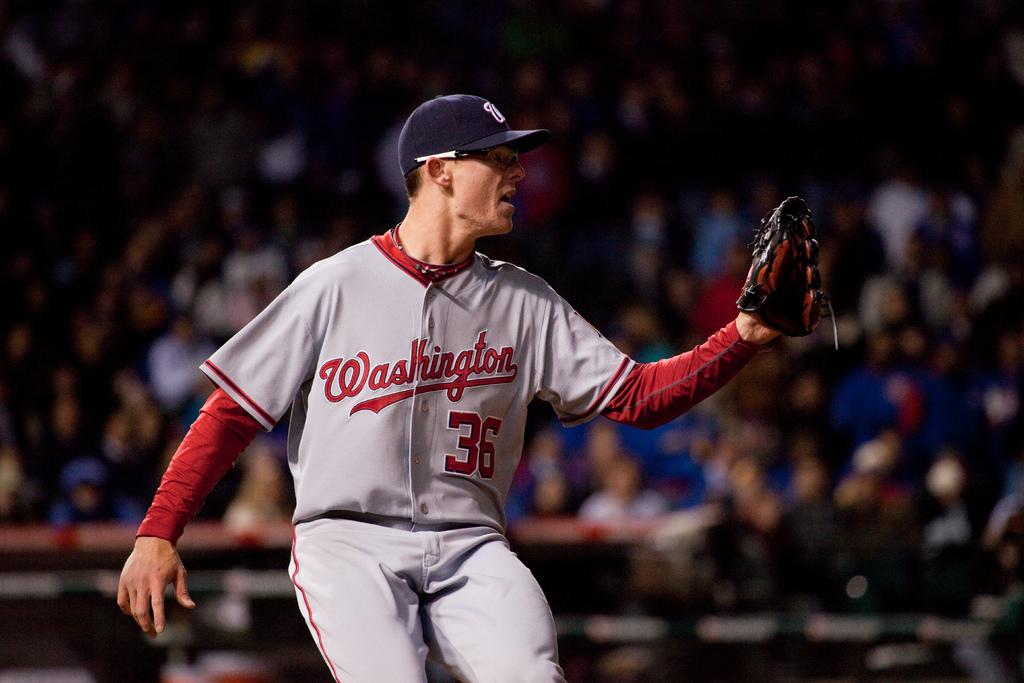What is the players number?
Your response must be concise. 36. 